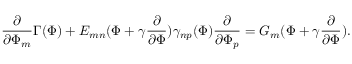<formula> <loc_0><loc_0><loc_500><loc_500>\frac { \partial } { \partial \Phi _ { m } } \Gamma ( \Phi ) + E _ { m n } ( \Phi + \gamma \frac { \partial } { \partial \Phi } ) \gamma _ { n p } ( \Phi ) \frac { \partial } { \partial \Phi _ { p } } = G _ { m } ( \Phi + \gamma \frac { \partial } { \partial \Phi } ) .</formula> 